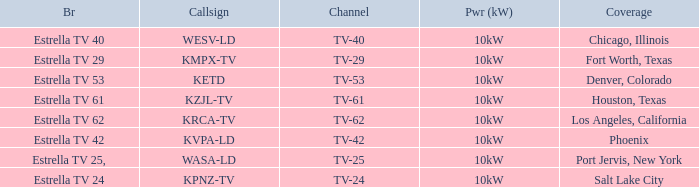What's the power output for channel tv-29? 10kW. 